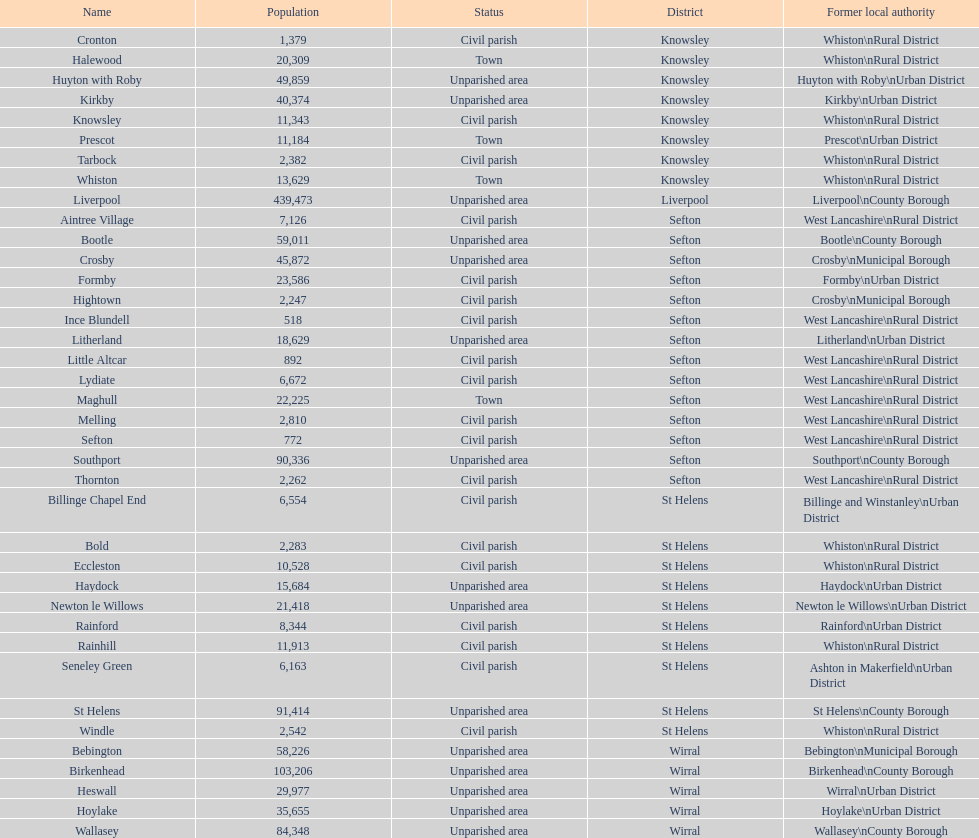I'm looking to parse the entire table for insights. Could you assist me with that? {'header': ['Name', 'Population', 'Status', 'District', 'Former local authority'], 'rows': [['Cronton', '1,379', 'Civil parish', 'Knowsley', 'Whiston\\nRural District'], ['Halewood', '20,309', 'Town', 'Knowsley', 'Whiston\\nRural District'], ['Huyton with Roby', '49,859', 'Unparished area', 'Knowsley', 'Huyton with Roby\\nUrban District'], ['Kirkby', '40,374', 'Unparished area', 'Knowsley', 'Kirkby\\nUrban District'], ['Knowsley', '11,343', 'Civil parish', 'Knowsley', 'Whiston\\nRural District'], ['Prescot', '11,184', 'Town', 'Knowsley', 'Prescot\\nUrban District'], ['Tarbock', '2,382', 'Civil parish', 'Knowsley', 'Whiston\\nRural District'], ['Whiston', '13,629', 'Town', 'Knowsley', 'Whiston\\nRural District'], ['Liverpool', '439,473', 'Unparished area', 'Liverpool', 'Liverpool\\nCounty Borough'], ['Aintree Village', '7,126', 'Civil parish', 'Sefton', 'West Lancashire\\nRural District'], ['Bootle', '59,011', 'Unparished area', 'Sefton', 'Bootle\\nCounty Borough'], ['Crosby', '45,872', 'Unparished area', 'Sefton', 'Crosby\\nMunicipal Borough'], ['Formby', '23,586', 'Civil parish', 'Sefton', 'Formby\\nUrban District'], ['Hightown', '2,247', 'Civil parish', 'Sefton', 'Crosby\\nMunicipal Borough'], ['Ince Blundell', '518', 'Civil parish', 'Sefton', 'West Lancashire\\nRural District'], ['Litherland', '18,629', 'Unparished area', 'Sefton', 'Litherland\\nUrban District'], ['Little Altcar', '892', 'Civil parish', 'Sefton', 'West Lancashire\\nRural District'], ['Lydiate', '6,672', 'Civil parish', 'Sefton', 'West Lancashire\\nRural District'], ['Maghull', '22,225', 'Town', 'Sefton', 'West Lancashire\\nRural District'], ['Melling', '2,810', 'Civil parish', 'Sefton', 'West Lancashire\\nRural District'], ['Sefton', '772', 'Civil parish', 'Sefton', 'West Lancashire\\nRural District'], ['Southport', '90,336', 'Unparished area', 'Sefton', 'Southport\\nCounty Borough'], ['Thornton', '2,262', 'Civil parish', 'Sefton', 'West Lancashire\\nRural District'], ['Billinge Chapel End', '6,554', 'Civil parish', 'St Helens', 'Billinge and Winstanley\\nUrban District'], ['Bold', '2,283', 'Civil parish', 'St Helens', 'Whiston\\nRural District'], ['Eccleston', '10,528', 'Civil parish', 'St Helens', 'Whiston\\nRural District'], ['Haydock', '15,684', 'Unparished area', 'St Helens', 'Haydock\\nUrban District'], ['Newton le Willows', '21,418', 'Unparished area', 'St Helens', 'Newton le Willows\\nUrban District'], ['Rainford', '8,344', 'Civil parish', 'St Helens', 'Rainford\\nUrban District'], ['Rainhill', '11,913', 'Civil parish', 'St Helens', 'Whiston\\nRural District'], ['Seneley Green', '6,163', 'Civil parish', 'St Helens', 'Ashton in Makerfield\\nUrban District'], ['St Helens', '91,414', 'Unparished area', 'St Helens', 'St Helens\\nCounty Borough'], ['Windle', '2,542', 'Civil parish', 'St Helens', 'Whiston\\nRural District'], ['Bebington', '58,226', 'Unparished area', 'Wirral', 'Bebington\\nMunicipal Borough'], ['Birkenhead', '103,206', 'Unparished area', 'Wirral', 'Birkenhead\\nCounty Borough'], ['Heswall', '29,977', 'Unparished area', 'Wirral', 'Wirral\\nUrban District'], ['Hoylake', '35,655', 'Unparished area', 'Wirral', 'Hoylake\\nUrban District'], ['Wallasey', '84,348', 'Unparished area', 'Wirral', 'Wallasey\\nCounty Borough']]} How many areas are unparished areas? 15. 